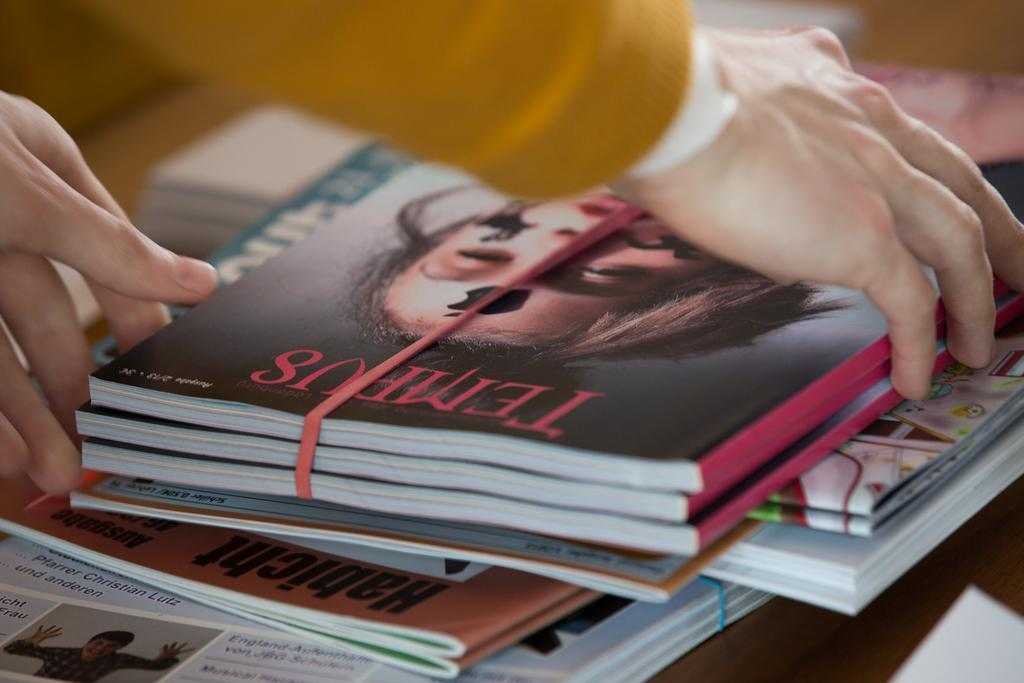What is the person in the image holding? The person in the image is holding books. Can you describe the arrangement of books in the image? There are many books stacked at the bottom of the image. What type of goose can be seen swimming near the coast in the image? There is no goose or coast present in the image; it features a person holding books and a stack of books. 